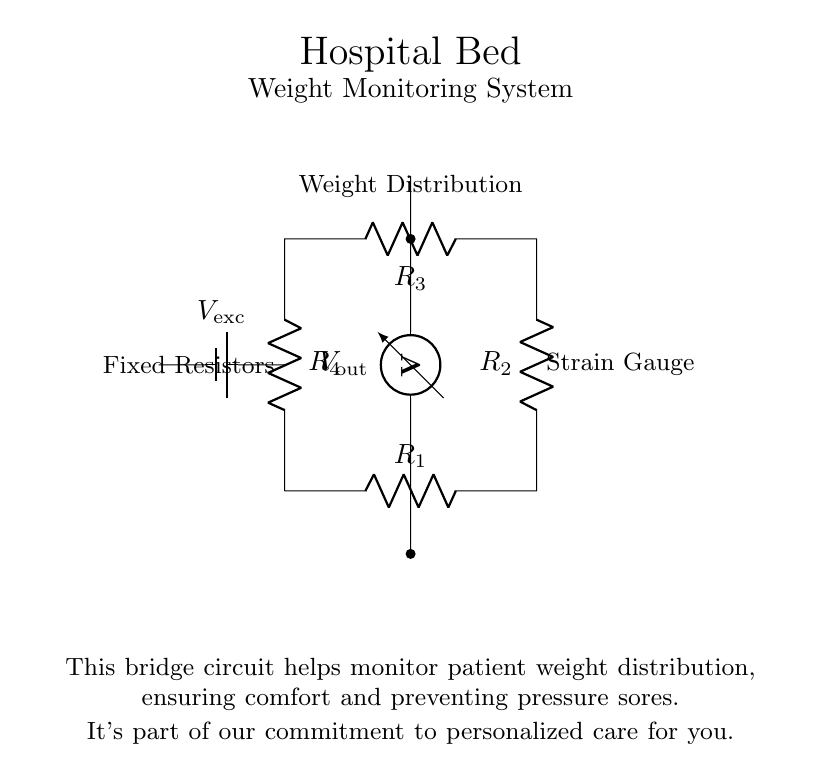What type of circuit is this? This circuit is a Wheatstone bridge, which is specifically designed for measuring electrical resistance changes, commonly used in sensing applications like strain gauges.
Answer: Wheatstone bridge What does the voltage source represent? The voltage source provides the excitation voltage needed to power the strain gauges and allows the measurement of resistance changes in the bridge circuit when the weight changes.
Answer: Excitation voltage What do the resistors R1, R2, R3, and R4 represent? R1, R2, R3, and R4 consist of fixed resistors that balance the bridge circuit and help in measuring changes in resistance due to strain in the gauges.
Answer: Fixed resistors What is the role of the voltmeter in this circuit? The voltmeter measures the voltage difference (output voltage) between the output terminals, which indicates the change in resistance due to weight distribution changes, helping to monitor the patient's weight.
Answer: Measure output voltage How does changing weight affect the circuit? When weight is applied to the bed, the strain gauges change their resistance, causing an imbalance in the bridge circuit, which in turn changes the output voltage measured by the voltmeter, reflecting the weight distribution.
Answer: Changes output voltage What is the purpose of this circuit in a hospital bed? This circuit monitors the weight distribution to improve patient comfort and prevent pressure sores, demonstrating the hospital's commitment to personalized care for each patient.
Answer: Monitor weight distribution What does the label "Weight Distribution" signify? This label indicates that the circuit is designed to monitor and measure how weight is distributed across the hospital bed, which is crucial for patient care and comfort.
Answer: Monitor weight distribution 